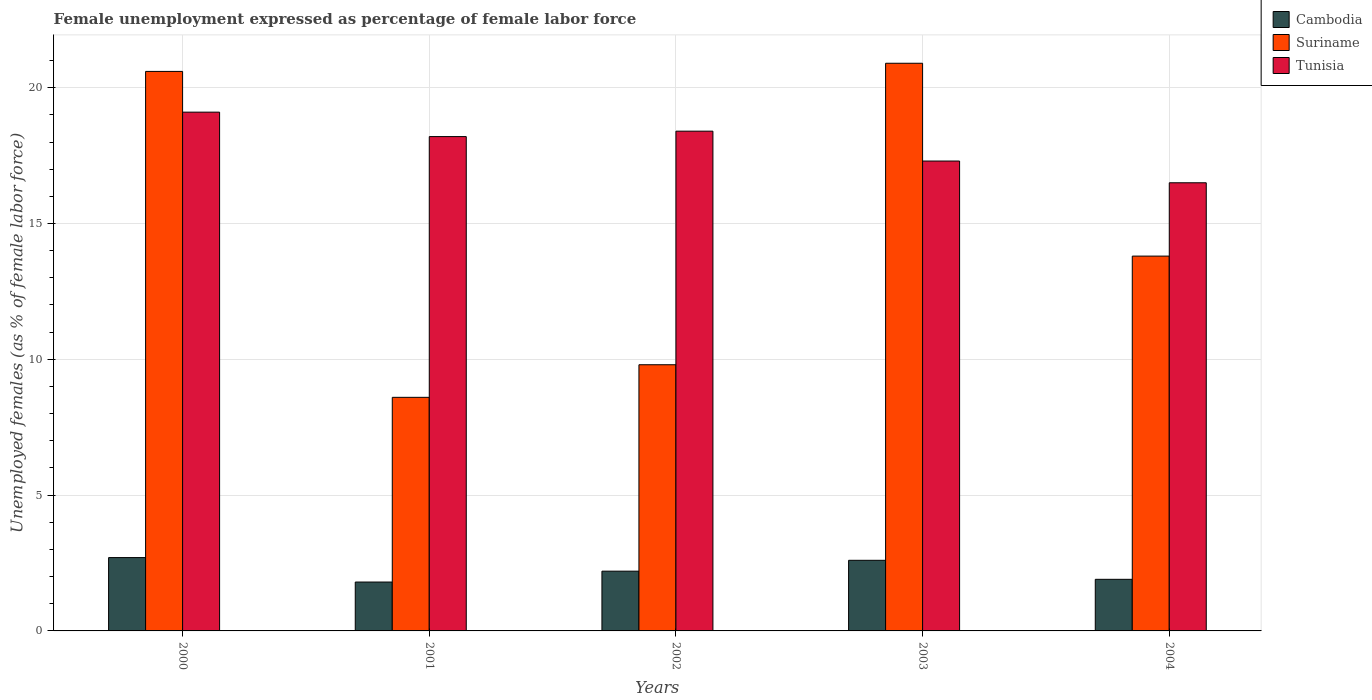How many different coloured bars are there?
Provide a succinct answer. 3. Are the number of bars on each tick of the X-axis equal?
Make the answer very short. Yes. How many bars are there on the 1st tick from the right?
Provide a succinct answer. 3. What is the unemployment in females in in Suriname in 2000?
Give a very brief answer. 20.6. Across all years, what is the maximum unemployment in females in in Suriname?
Provide a short and direct response. 20.9. Across all years, what is the minimum unemployment in females in in Suriname?
Your answer should be very brief. 8.6. What is the total unemployment in females in in Suriname in the graph?
Ensure brevity in your answer.  73.7. What is the difference between the unemployment in females in in Cambodia in 2002 and that in 2004?
Offer a terse response. 0.3. What is the average unemployment in females in in Suriname per year?
Offer a terse response. 14.74. In the year 2000, what is the difference between the unemployment in females in in Tunisia and unemployment in females in in Suriname?
Keep it short and to the point. -1.5. What is the ratio of the unemployment in females in in Suriname in 2000 to that in 2002?
Your answer should be very brief. 2.1. Is the unemployment in females in in Tunisia in 2002 less than that in 2003?
Your answer should be very brief. No. Is the difference between the unemployment in females in in Tunisia in 2001 and 2004 greater than the difference between the unemployment in females in in Suriname in 2001 and 2004?
Give a very brief answer. Yes. What is the difference between the highest and the second highest unemployment in females in in Suriname?
Offer a terse response. 0.3. What is the difference between the highest and the lowest unemployment in females in in Cambodia?
Your answer should be very brief. 0.9. In how many years, is the unemployment in females in in Suriname greater than the average unemployment in females in in Suriname taken over all years?
Your response must be concise. 2. What does the 3rd bar from the left in 2004 represents?
Your response must be concise. Tunisia. What does the 3rd bar from the right in 2001 represents?
Your answer should be compact. Cambodia. Is it the case that in every year, the sum of the unemployment in females in in Suriname and unemployment in females in in Cambodia is greater than the unemployment in females in in Tunisia?
Give a very brief answer. No. What is the difference between two consecutive major ticks on the Y-axis?
Your answer should be compact. 5. Are the values on the major ticks of Y-axis written in scientific E-notation?
Your answer should be very brief. No. How many legend labels are there?
Your answer should be compact. 3. How are the legend labels stacked?
Offer a terse response. Vertical. What is the title of the graph?
Provide a succinct answer. Female unemployment expressed as percentage of female labor force. What is the label or title of the X-axis?
Give a very brief answer. Years. What is the label or title of the Y-axis?
Your answer should be very brief. Unemployed females (as % of female labor force). What is the Unemployed females (as % of female labor force) of Cambodia in 2000?
Your answer should be compact. 2.7. What is the Unemployed females (as % of female labor force) in Suriname in 2000?
Your response must be concise. 20.6. What is the Unemployed females (as % of female labor force) of Tunisia in 2000?
Keep it short and to the point. 19.1. What is the Unemployed females (as % of female labor force) of Cambodia in 2001?
Offer a terse response. 1.8. What is the Unemployed females (as % of female labor force) of Suriname in 2001?
Give a very brief answer. 8.6. What is the Unemployed females (as % of female labor force) in Tunisia in 2001?
Give a very brief answer. 18.2. What is the Unemployed females (as % of female labor force) in Cambodia in 2002?
Give a very brief answer. 2.2. What is the Unemployed females (as % of female labor force) of Suriname in 2002?
Provide a succinct answer. 9.8. What is the Unemployed females (as % of female labor force) in Tunisia in 2002?
Provide a short and direct response. 18.4. What is the Unemployed females (as % of female labor force) of Cambodia in 2003?
Provide a succinct answer. 2.6. What is the Unemployed females (as % of female labor force) in Suriname in 2003?
Provide a short and direct response. 20.9. What is the Unemployed females (as % of female labor force) in Tunisia in 2003?
Your response must be concise. 17.3. What is the Unemployed females (as % of female labor force) in Cambodia in 2004?
Your answer should be very brief. 1.9. What is the Unemployed females (as % of female labor force) of Suriname in 2004?
Give a very brief answer. 13.8. What is the Unemployed females (as % of female labor force) in Tunisia in 2004?
Give a very brief answer. 16.5. Across all years, what is the maximum Unemployed females (as % of female labor force) in Cambodia?
Give a very brief answer. 2.7. Across all years, what is the maximum Unemployed females (as % of female labor force) of Suriname?
Provide a succinct answer. 20.9. Across all years, what is the maximum Unemployed females (as % of female labor force) in Tunisia?
Provide a succinct answer. 19.1. Across all years, what is the minimum Unemployed females (as % of female labor force) of Cambodia?
Keep it short and to the point. 1.8. Across all years, what is the minimum Unemployed females (as % of female labor force) in Suriname?
Your answer should be compact. 8.6. What is the total Unemployed females (as % of female labor force) of Suriname in the graph?
Offer a very short reply. 73.7. What is the total Unemployed females (as % of female labor force) of Tunisia in the graph?
Offer a very short reply. 89.5. What is the difference between the Unemployed females (as % of female labor force) of Cambodia in 2000 and that in 2001?
Give a very brief answer. 0.9. What is the difference between the Unemployed females (as % of female labor force) in Suriname in 2000 and that in 2001?
Make the answer very short. 12. What is the difference between the Unemployed females (as % of female labor force) of Cambodia in 2000 and that in 2002?
Give a very brief answer. 0.5. What is the difference between the Unemployed females (as % of female labor force) in Tunisia in 2000 and that in 2003?
Your answer should be very brief. 1.8. What is the difference between the Unemployed females (as % of female labor force) of Cambodia in 2001 and that in 2002?
Provide a succinct answer. -0.4. What is the difference between the Unemployed females (as % of female labor force) in Suriname in 2001 and that in 2003?
Provide a short and direct response. -12.3. What is the difference between the Unemployed females (as % of female labor force) in Suriname in 2001 and that in 2004?
Give a very brief answer. -5.2. What is the difference between the Unemployed females (as % of female labor force) in Cambodia in 2002 and that in 2003?
Make the answer very short. -0.4. What is the difference between the Unemployed females (as % of female labor force) of Tunisia in 2002 and that in 2003?
Your answer should be compact. 1.1. What is the difference between the Unemployed females (as % of female labor force) in Suriname in 2002 and that in 2004?
Make the answer very short. -4. What is the difference between the Unemployed females (as % of female labor force) in Tunisia in 2002 and that in 2004?
Provide a succinct answer. 1.9. What is the difference between the Unemployed females (as % of female labor force) in Cambodia in 2003 and that in 2004?
Give a very brief answer. 0.7. What is the difference between the Unemployed females (as % of female labor force) in Suriname in 2003 and that in 2004?
Your response must be concise. 7.1. What is the difference between the Unemployed females (as % of female labor force) in Tunisia in 2003 and that in 2004?
Provide a short and direct response. 0.8. What is the difference between the Unemployed females (as % of female labor force) of Cambodia in 2000 and the Unemployed females (as % of female labor force) of Tunisia in 2001?
Your answer should be very brief. -15.5. What is the difference between the Unemployed females (as % of female labor force) of Cambodia in 2000 and the Unemployed females (as % of female labor force) of Tunisia in 2002?
Give a very brief answer. -15.7. What is the difference between the Unemployed females (as % of female labor force) of Cambodia in 2000 and the Unemployed females (as % of female labor force) of Suriname in 2003?
Your answer should be very brief. -18.2. What is the difference between the Unemployed females (as % of female labor force) in Cambodia in 2000 and the Unemployed females (as % of female labor force) in Tunisia in 2003?
Offer a terse response. -14.6. What is the difference between the Unemployed females (as % of female labor force) in Suriname in 2000 and the Unemployed females (as % of female labor force) in Tunisia in 2003?
Offer a terse response. 3.3. What is the difference between the Unemployed females (as % of female labor force) in Cambodia in 2000 and the Unemployed females (as % of female labor force) in Suriname in 2004?
Make the answer very short. -11.1. What is the difference between the Unemployed females (as % of female labor force) of Cambodia in 2001 and the Unemployed females (as % of female labor force) of Tunisia in 2002?
Your answer should be very brief. -16.6. What is the difference between the Unemployed females (as % of female labor force) in Cambodia in 2001 and the Unemployed females (as % of female labor force) in Suriname in 2003?
Offer a terse response. -19.1. What is the difference between the Unemployed females (as % of female labor force) of Cambodia in 2001 and the Unemployed females (as % of female labor force) of Tunisia in 2003?
Your answer should be compact. -15.5. What is the difference between the Unemployed females (as % of female labor force) in Cambodia in 2001 and the Unemployed females (as % of female labor force) in Suriname in 2004?
Provide a succinct answer. -12. What is the difference between the Unemployed females (as % of female labor force) in Cambodia in 2001 and the Unemployed females (as % of female labor force) in Tunisia in 2004?
Keep it short and to the point. -14.7. What is the difference between the Unemployed females (as % of female labor force) of Cambodia in 2002 and the Unemployed females (as % of female labor force) of Suriname in 2003?
Make the answer very short. -18.7. What is the difference between the Unemployed females (as % of female labor force) in Cambodia in 2002 and the Unemployed females (as % of female labor force) in Tunisia in 2003?
Keep it short and to the point. -15.1. What is the difference between the Unemployed females (as % of female labor force) in Cambodia in 2002 and the Unemployed females (as % of female labor force) in Tunisia in 2004?
Provide a succinct answer. -14.3. What is the difference between the Unemployed females (as % of female labor force) in Suriname in 2002 and the Unemployed females (as % of female labor force) in Tunisia in 2004?
Ensure brevity in your answer.  -6.7. What is the average Unemployed females (as % of female labor force) of Cambodia per year?
Provide a succinct answer. 2.24. What is the average Unemployed females (as % of female labor force) in Suriname per year?
Make the answer very short. 14.74. In the year 2000, what is the difference between the Unemployed females (as % of female labor force) in Cambodia and Unemployed females (as % of female labor force) in Suriname?
Give a very brief answer. -17.9. In the year 2000, what is the difference between the Unemployed females (as % of female labor force) in Cambodia and Unemployed females (as % of female labor force) in Tunisia?
Your answer should be compact. -16.4. In the year 2000, what is the difference between the Unemployed females (as % of female labor force) in Suriname and Unemployed females (as % of female labor force) in Tunisia?
Your response must be concise. 1.5. In the year 2001, what is the difference between the Unemployed females (as % of female labor force) of Cambodia and Unemployed females (as % of female labor force) of Suriname?
Make the answer very short. -6.8. In the year 2001, what is the difference between the Unemployed females (as % of female labor force) of Cambodia and Unemployed females (as % of female labor force) of Tunisia?
Give a very brief answer. -16.4. In the year 2001, what is the difference between the Unemployed females (as % of female labor force) in Suriname and Unemployed females (as % of female labor force) in Tunisia?
Keep it short and to the point. -9.6. In the year 2002, what is the difference between the Unemployed females (as % of female labor force) in Cambodia and Unemployed females (as % of female labor force) in Suriname?
Make the answer very short. -7.6. In the year 2002, what is the difference between the Unemployed females (as % of female labor force) of Cambodia and Unemployed females (as % of female labor force) of Tunisia?
Keep it short and to the point. -16.2. In the year 2002, what is the difference between the Unemployed females (as % of female labor force) of Suriname and Unemployed females (as % of female labor force) of Tunisia?
Keep it short and to the point. -8.6. In the year 2003, what is the difference between the Unemployed females (as % of female labor force) of Cambodia and Unemployed females (as % of female labor force) of Suriname?
Ensure brevity in your answer.  -18.3. In the year 2003, what is the difference between the Unemployed females (as % of female labor force) of Cambodia and Unemployed females (as % of female labor force) of Tunisia?
Keep it short and to the point. -14.7. In the year 2003, what is the difference between the Unemployed females (as % of female labor force) in Suriname and Unemployed females (as % of female labor force) in Tunisia?
Offer a very short reply. 3.6. In the year 2004, what is the difference between the Unemployed females (as % of female labor force) in Cambodia and Unemployed females (as % of female labor force) in Suriname?
Give a very brief answer. -11.9. In the year 2004, what is the difference between the Unemployed females (as % of female labor force) of Cambodia and Unemployed females (as % of female labor force) of Tunisia?
Offer a very short reply. -14.6. In the year 2004, what is the difference between the Unemployed females (as % of female labor force) of Suriname and Unemployed females (as % of female labor force) of Tunisia?
Keep it short and to the point. -2.7. What is the ratio of the Unemployed females (as % of female labor force) in Suriname in 2000 to that in 2001?
Your response must be concise. 2.4. What is the ratio of the Unemployed females (as % of female labor force) in Tunisia in 2000 to that in 2001?
Make the answer very short. 1.05. What is the ratio of the Unemployed females (as % of female labor force) in Cambodia in 2000 to that in 2002?
Ensure brevity in your answer.  1.23. What is the ratio of the Unemployed females (as % of female labor force) of Suriname in 2000 to that in 2002?
Give a very brief answer. 2.1. What is the ratio of the Unemployed females (as % of female labor force) of Tunisia in 2000 to that in 2002?
Ensure brevity in your answer.  1.04. What is the ratio of the Unemployed females (as % of female labor force) of Suriname in 2000 to that in 2003?
Offer a very short reply. 0.99. What is the ratio of the Unemployed females (as % of female labor force) in Tunisia in 2000 to that in 2003?
Make the answer very short. 1.1. What is the ratio of the Unemployed females (as % of female labor force) of Cambodia in 2000 to that in 2004?
Keep it short and to the point. 1.42. What is the ratio of the Unemployed females (as % of female labor force) in Suriname in 2000 to that in 2004?
Your answer should be compact. 1.49. What is the ratio of the Unemployed females (as % of female labor force) of Tunisia in 2000 to that in 2004?
Ensure brevity in your answer.  1.16. What is the ratio of the Unemployed females (as % of female labor force) of Cambodia in 2001 to that in 2002?
Your response must be concise. 0.82. What is the ratio of the Unemployed females (as % of female labor force) of Suriname in 2001 to that in 2002?
Offer a very short reply. 0.88. What is the ratio of the Unemployed females (as % of female labor force) in Tunisia in 2001 to that in 2002?
Provide a succinct answer. 0.99. What is the ratio of the Unemployed females (as % of female labor force) of Cambodia in 2001 to that in 2003?
Ensure brevity in your answer.  0.69. What is the ratio of the Unemployed females (as % of female labor force) in Suriname in 2001 to that in 2003?
Your response must be concise. 0.41. What is the ratio of the Unemployed females (as % of female labor force) in Tunisia in 2001 to that in 2003?
Ensure brevity in your answer.  1.05. What is the ratio of the Unemployed females (as % of female labor force) in Cambodia in 2001 to that in 2004?
Your answer should be very brief. 0.95. What is the ratio of the Unemployed females (as % of female labor force) in Suriname in 2001 to that in 2004?
Your answer should be compact. 0.62. What is the ratio of the Unemployed females (as % of female labor force) of Tunisia in 2001 to that in 2004?
Give a very brief answer. 1.1. What is the ratio of the Unemployed females (as % of female labor force) of Cambodia in 2002 to that in 2003?
Offer a terse response. 0.85. What is the ratio of the Unemployed females (as % of female labor force) of Suriname in 2002 to that in 2003?
Your response must be concise. 0.47. What is the ratio of the Unemployed females (as % of female labor force) in Tunisia in 2002 to that in 2003?
Your response must be concise. 1.06. What is the ratio of the Unemployed females (as % of female labor force) of Cambodia in 2002 to that in 2004?
Offer a very short reply. 1.16. What is the ratio of the Unemployed females (as % of female labor force) in Suriname in 2002 to that in 2004?
Provide a short and direct response. 0.71. What is the ratio of the Unemployed females (as % of female labor force) of Tunisia in 2002 to that in 2004?
Offer a terse response. 1.12. What is the ratio of the Unemployed females (as % of female labor force) of Cambodia in 2003 to that in 2004?
Make the answer very short. 1.37. What is the ratio of the Unemployed females (as % of female labor force) of Suriname in 2003 to that in 2004?
Make the answer very short. 1.51. What is the ratio of the Unemployed females (as % of female labor force) of Tunisia in 2003 to that in 2004?
Offer a terse response. 1.05. What is the difference between the highest and the lowest Unemployed females (as % of female labor force) in Cambodia?
Provide a short and direct response. 0.9. What is the difference between the highest and the lowest Unemployed females (as % of female labor force) in Suriname?
Offer a terse response. 12.3. 